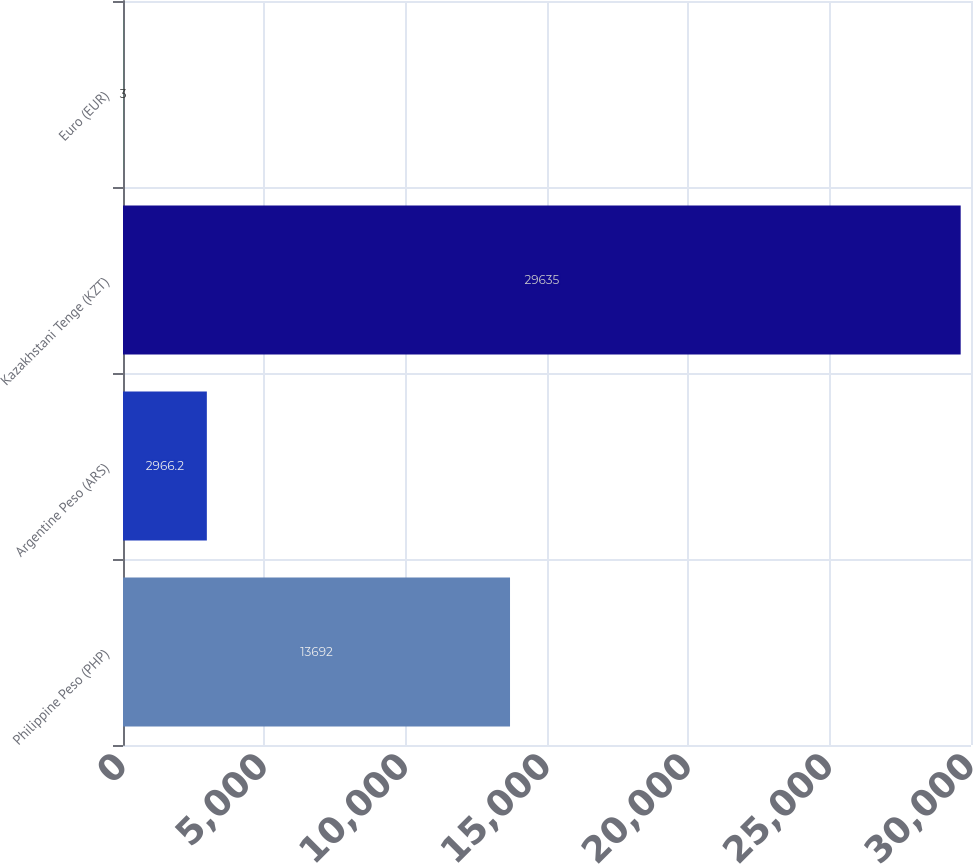<chart> <loc_0><loc_0><loc_500><loc_500><bar_chart><fcel>Philippine Peso (PHP)<fcel>Argentine Peso (ARS)<fcel>Kazakhstani Tenge (KZT)<fcel>Euro (EUR)<nl><fcel>13692<fcel>2966.2<fcel>29635<fcel>3<nl></chart> 